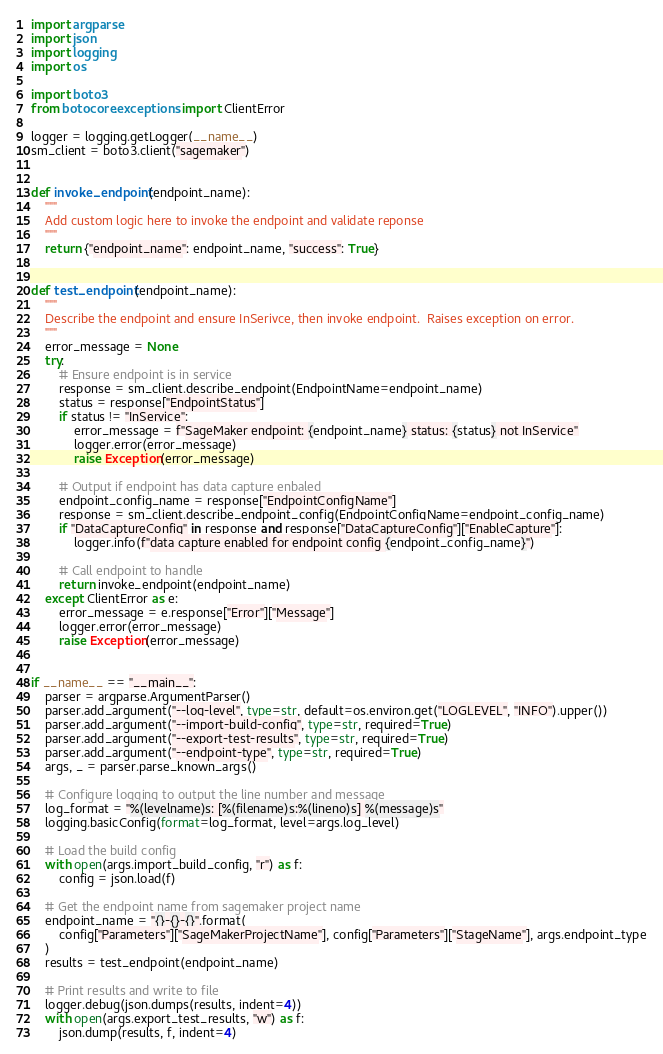Convert code to text. <code><loc_0><loc_0><loc_500><loc_500><_Python_>import argparse
import json
import logging
import os

import boto3
from botocore.exceptions import ClientError

logger = logging.getLogger(__name__)
sm_client = boto3.client("sagemaker")


def invoke_endpoint(endpoint_name):
    """
    Add custom logic here to invoke the endpoint and validate reponse
    """
    return {"endpoint_name": endpoint_name, "success": True}


def test_endpoint(endpoint_name):
    """
    Describe the endpoint and ensure InSerivce, then invoke endpoint.  Raises exception on error.
    """
    error_message = None
    try:
        # Ensure endpoint is in service
        response = sm_client.describe_endpoint(EndpointName=endpoint_name)
        status = response["EndpointStatus"]
        if status != "InService":
            error_message = f"SageMaker endpoint: {endpoint_name} status: {status} not InService"
            logger.error(error_message)
            raise Exception(error_message)

        # Output if endpoint has data capture enbaled
        endpoint_config_name = response["EndpointConfigName"]
        response = sm_client.describe_endpoint_config(EndpointConfigName=endpoint_config_name)
        if "DataCaptureConfig" in response and response["DataCaptureConfig"]["EnableCapture"]:
            logger.info(f"data capture enabled for endpoint config {endpoint_config_name}")

        # Call endpoint to handle
        return invoke_endpoint(endpoint_name)
    except ClientError as e:
        error_message = e.response["Error"]["Message"]
        logger.error(error_message)
        raise Exception(error_message)


if __name__ == "__main__":
    parser = argparse.ArgumentParser()
    parser.add_argument("--log-level", type=str, default=os.environ.get("LOGLEVEL", "INFO").upper())
    parser.add_argument("--import-build-config", type=str, required=True)
    parser.add_argument("--export-test-results", type=str, required=True)
    parser.add_argument("--endpoint-type", type=str, required=True)
    args, _ = parser.parse_known_args()

    # Configure logging to output the line number and message
    log_format = "%(levelname)s: [%(filename)s:%(lineno)s] %(message)s"
    logging.basicConfig(format=log_format, level=args.log_level)

    # Load the build config
    with open(args.import_build_config, "r") as f:
        config = json.load(f)

    # Get the endpoint name from sagemaker project name
    endpoint_name = "{}-{}-{}".format(
        config["Parameters"]["SageMakerProjectName"], config["Parameters"]["StageName"], args.endpoint_type
    )
    results = test_endpoint(endpoint_name)

    # Print results and write to file
    logger.debug(json.dumps(results, indent=4))
    with open(args.export_test_results, "w") as f:
        json.dump(results, f, indent=4)
</code> 